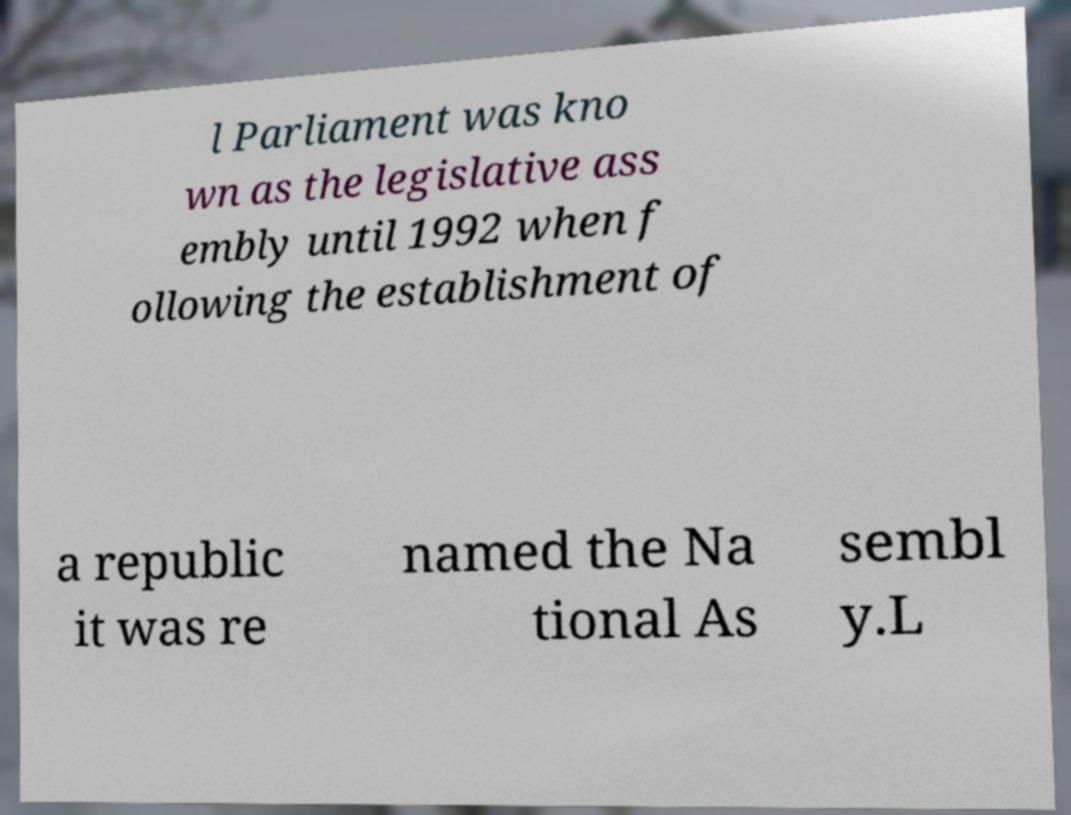Please read and relay the text visible in this image. What does it say? l Parliament was kno wn as the legislative ass embly until 1992 when f ollowing the establishment of a republic it was re named the Na tional As sembl y.L 